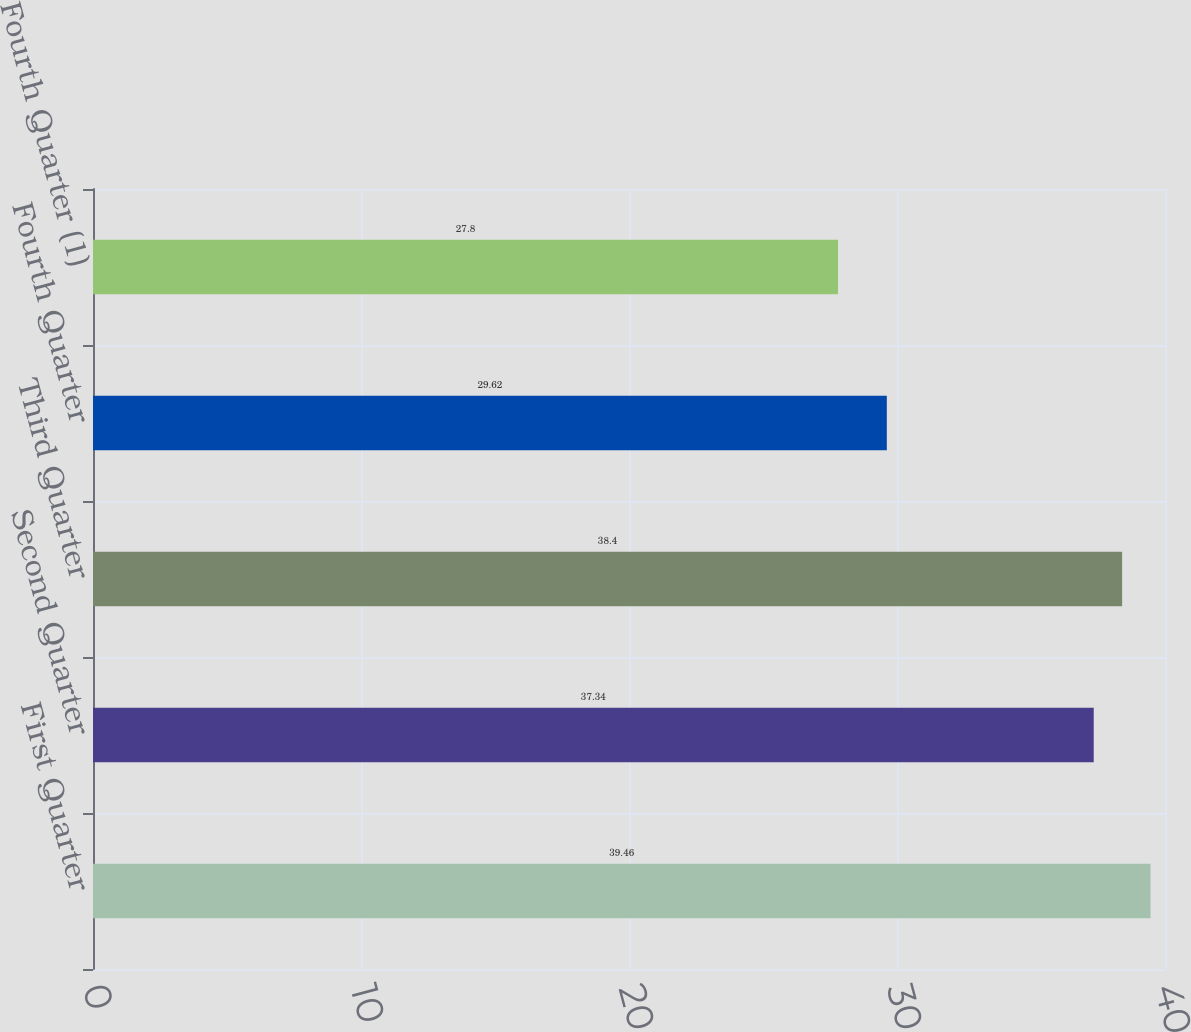<chart> <loc_0><loc_0><loc_500><loc_500><bar_chart><fcel>First Quarter<fcel>Second Quarter<fcel>Third Quarter<fcel>Fourth Quarter<fcel>Fourth Quarter (1)<nl><fcel>39.46<fcel>37.34<fcel>38.4<fcel>29.62<fcel>27.8<nl></chart> 